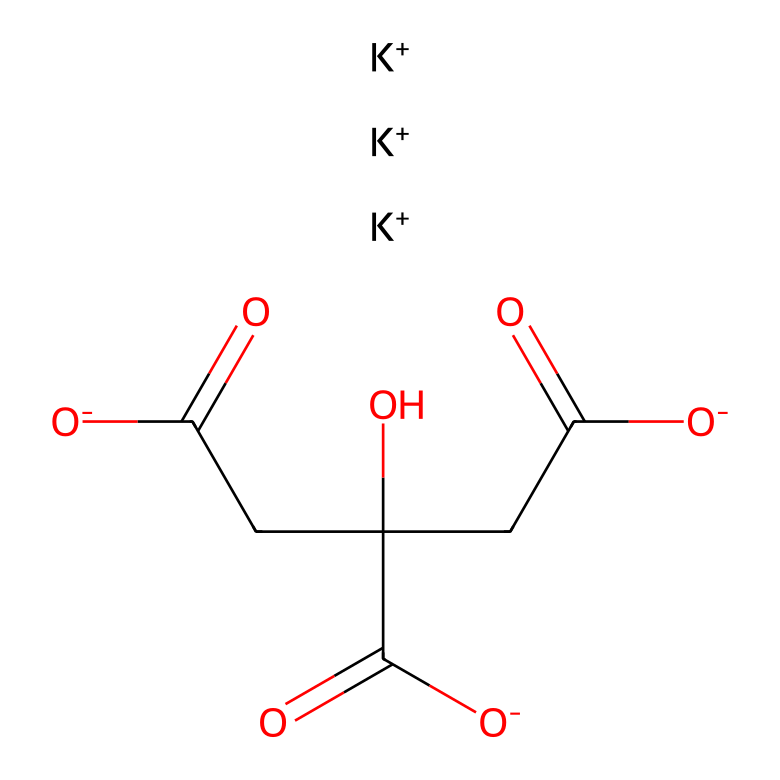What is the total number of potassium ions in this compound? The SMILES representation shows three instances of [K+], indicating there are three potassium ions present in the molecular composition.
Answer: three How many carboxylate groups are present in the structure? The structure has three instances of [O-] associated with carbon atoms, indicating three carboxylate groups (COO-) that are negatively charged.
Answer: three What type of molecule is this compound classified as based on its function? Potassium citrate serves as an electrolyte due to its ability to dissociate into ions in solution, making it categorized as an electrolyte.
Answer: electrolyte Which element has the highest electronegativity in this compound? Among the elements present, oxygen has the highest electronegativity compared to potassium or carbon, making it the most electronegative element.
Answer: oxygen What type of interaction in the solution allows potassium citrate to function as an electrolyte? The dissociation of the compound into its constituent ions (cations and anions) in solution enables the conduction of electricity, which characterizes its function as an electrolyte.
Answer: dissociation How many carbon atoms are present in this molecule? By examining the structure in the SMILES notation, we can count five instances of carbon in the form of C and its connections to other atoms, confirming a total of five carbon atoms.
Answer: five 